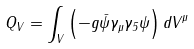Convert formula to latex. <formula><loc_0><loc_0><loc_500><loc_500>Q _ { V } = \int _ { V } \left ( - g \bar { \psi } \gamma _ { \mu } \gamma _ { 5 } \psi \right ) d V ^ { \mu }</formula> 